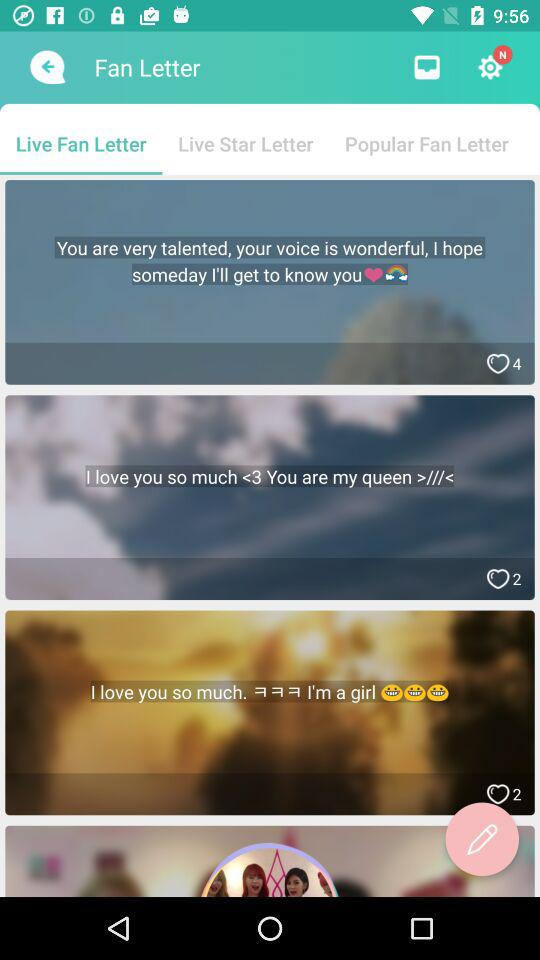Which live fan letter has four likes? The live fan letter that has four likes is "You are very talented, your voice is wonderful, I hope someday I'll get to know you". 